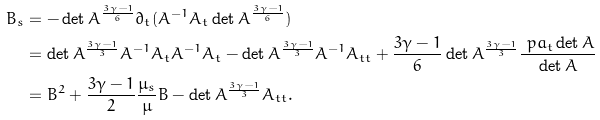<formula> <loc_0><loc_0><loc_500><loc_500>B _ { s } & = - \det A ^ { \frac { 3 \gamma - 1 } { 6 } } \partial _ { t } ( A ^ { - 1 } A _ { t } \det { A } ^ { \frac { 3 \gamma - 1 } { 6 } } ) \\ & = \det { A } ^ { \frac { 3 \gamma - 1 } 3 } A ^ { - 1 } A _ { t } A ^ { - 1 } A _ { t } - \det { A } ^ { \frac { 3 \gamma - 1 } 3 } A ^ { - 1 } A _ { t t } + \frac { 3 \gamma - 1 } { 6 } \det { A } ^ { \frac { 3 \gamma - 1 } 3 } \frac { \ p a _ { t } \det { A } } { \det { A } } \\ & = B ^ { 2 } + \frac { 3 \gamma - 1 } { 2 } \frac { \mu _ { s } } { \mu } B - \det { A } ^ { \frac { 3 \gamma - 1 } 3 } A _ { t t } .</formula> 